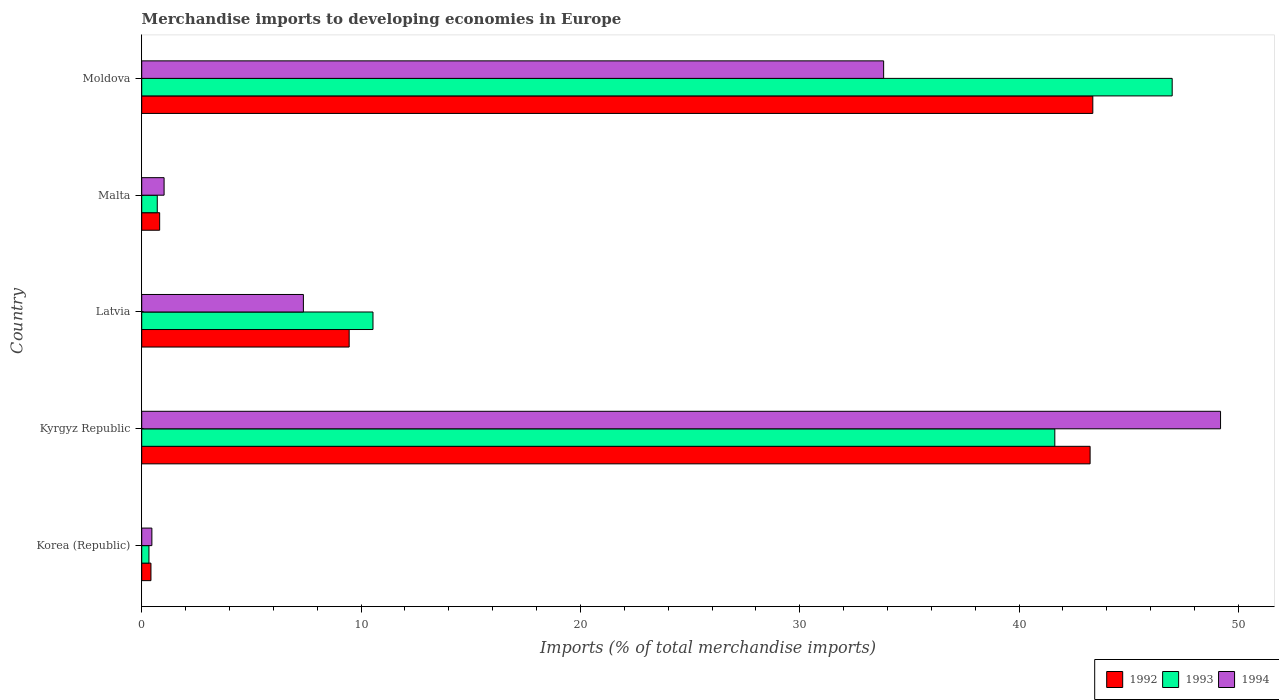Are the number of bars on each tick of the Y-axis equal?
Offer a terse response. Yes. How many bars are there on the 3rd tick from the bottom?
Keep it short and to the point. 3. What is the label of the 1st group of bars from the top?
Offer a terse response. Moldova. What is the percentage total merchandise imports in 1992 in Moldova?
Make the answer very short. 43.36. Across all countries, what is the maximum percentage total merchandise imports in 1992?
Offer a terse response. 43.36. Across all countries, what is the minimum percentage total merchandise imports in 1994?
Make the answer very short. 0.46. In which country was the percentage total merchandise imports in 1994 maximum?
Provide a short and direct response. Kyrgyz Republic. What is the total percentage total merchandise imports in 1992 in the graph?
Provide a short and direct response. 97.29. What is the difference between the percentage total merchandise imports in 1992 in Kyrgyz Republic and that in Malta?
Ensure brevity in your answer.  42.42. What is the difference between the percentage total merchandise imports in 1994 in Malta and the percentage total merchandise imports in 1993 in Korea (Republic)?
Offer a very short reply. 0.69. What is the average percentage total merchandise imports in 1992 per country?
Your answer should be compact. 19.46. What is the difference between the percentage total merchandise imports in 1994 and percentage total merchandise imports in 1993 in Moldova?
Your response must be concise. -13.15. What is the ratio of the percentage total merchandise imports in 1994 in Kyrgyz Republic to that in Latvia?
Provide a short and direct response. 6.67. Is the percentage total merchandise imports in 1992 in Kyrgyz Republic less than that in Malta?
Your answer should be compact. No. What is the difference between the highest and the second highest percentage total merchandise imports in 1993?
Your response must be concise. 5.35. What is the difference between the highest and the lowest percentage total merchandise imports in 1993?
Offer a terse response. 46.65. In how many countries, is the percentage total merchandise imports in 1993 greater than the average percentage total merchandise imports in 1993 taken over all countries?
Offer a terse response. 2. Is the sum of the percentage total merchandise imports in 1992 in Korea (Republic) and Kyrgyz Republic greater than the maximum percentage total merchandise imports in 1993 across all countries?
Your answer should be very brief. No. What does the 2nd bar from the top in Kyrgyz Republic represents?
Offer a very short reply. 1993. Is it the case that in every country, the sum of the percentage total merchandise imports in 1994 and percentage total merchandise imports in 1992 is greater than the percentage total merchandise imports in 1993?
Ensure brevity in your answer.  Yes. Are all the bars in the graph horizontal?
Make the answer very short. Yes. How many countries are there in the graph?
Give a very brief answer. 5. What is the difference between two consecutive major ticks on the X-axis?
Offer a very short reply. 10. Does the graph contain any zero values?
Provide a succinct answer. No. Does the graph contain grids?
Your response must be concise. No. Where does the legend appear in the graph?
Give a very brief answer. Bottom right. What is the title of the graph?
Give a very brief answer. Merchandise imports to developing economies in Europe. What is the label or title of the X-axis?
Give a very brief answer. Imports (% of total merchandise imports). What is the label or title of the Y-axis?
Your answer should be very brief. Country. What is the Imports (% of total merchandise imports) in 1992 in Korea (Republic)?
Offer a very short reply. 0.42. What is the Imports (% of total merchandise imports) of 1993 in Korea (Republic)?
Ensure brevity in your answer.  0.33. What is the Imports (% of total merchandise imports) of 1994 in Korea (Republic)?
Offer a very short reply. 0.46. What is the Imports (% of total merchandise imports) in 1992 in Kyrgyz Republic?
Your answer should be compact. 43.24. What is the Imports (% of total merchandise imports) in 1993 in Kyrgyz Republic?
Your answer should be very brief. 41.63. What is the Imports (% of total merchandise imports) in 1994 in Kyrgyz Republic?
Give a very brief answer. 49.18. What is the Imports (% of total merchandise imports) of 1992 in Latvia?
Keep it short and to the point. 9.46. What is the Imports (% of total merchandise imports) of 1993 in Latvia?
Ensure brevity in your answer.  10.54. What is the Imports (% of total merchandise imports) of 1994 in Latvia?
Make the answer very short. 7.37. What is the Imports (% of total merchandise imports) of 1992 in Malta?
Provide a short and direct response. 0.82. What is the Imports (% of total merchandise imports) of 1993 in Malta?
Make the answer very short. 0.71. What is the Imports (% of total merchandise imports) in 1994 in Malta?
Your answer should be compact. 1.02. What is the Imports (% of total merchandise imports) in 1992 in Moldova?
Provide a short and direct response. 43.36. What is the Imports (% of total merchandise imports) of 1993 in Moldova?
Provide a succinct answer. 46.98. What is the Imports (% of total merchandise imports) of 1994 in Moldova?
Make the answer very short. 33.82. Across all countries, what is the maximum Imports (% of total merchandise imports) in 1992?
Offer a very short reply. 43.36. Across all countries, what is the maximum Imports (% of total merchandise imports) in 1993?
Ensure brevity in your answer.  46.98. Across all countries, what is the maximum Imports (% of total merchandise imports) in 1994?
Keep it short and to the point. 49.18. Across all countries, what is the minimum Imports (% of total merchandise imports) in 1992?
Keep it short and to the point. 0.42. Across all countries, what is the minimum Imports (% of total merchandise imports) of 1993?
Offer a terse response. 0.33. Across all countries, what is the minimum Imports (% of total merchandise imports) in 1994?
Give a very brief answer. 0.46. What is the total Imports (% of total merchandise imports) of 1992 in the graph?
Ensure brevity in your answer.  97.29. What is the total Imports (% of total merchandise imports) in 1993 in the graph?
Provide a short and direct response. 100.19. What is the total Imports (% of total merchandise imports) of 1994 in the graph?
Your response must be concise. 91.86. What is the difference between the Imports (% of total merchandise imports) of 1992 in Korea (Republic) and that in Kyrgyz Republic?
Your answer should be very brief. -42.82. What is the difference between the Imports (% of total merchandise imports) in 1993 in Korea (Republic) and that in Kyrgyz Republic?
Your response must be concise. -41.3. What is the difference between the Imports (% of total merchandise imports) of 1994 in Korea (Republic) and that in Kyrgyz Republic?
Make the answer very short. -48.72. What is the difference between the Imports (% of total merchandise imports) in 1992 in Korea (Republic) and that in Latvia?
Offer a very short reply. -9.04. What is the difference between the Imports (% of total merchandise imports) of 1993 in Korea (Republic) and that in Latvia?
Your response must be concise. -10.21. What is the difference between the Imports (% of total merchandise imports) in 1994 in Korea (Republic) and that in Latvia?
Keep it short and to the point. -6.91. What is the difference between the Imports (% of total merchandise imports) in 1992 in Korea (Republic) and that in Malta?
Provide a succinct answer. -0.4. What is the difference between the Imports (% of total merchandise imports) in 1993 in Korea (Republic) and that in Malta?
Keep it short and to the point. -0.38. What is the difference between the Imports (% of total merchandise imports) of 1994 in Korea (Republic) and that in Malta?
Offer a terse response. -0.56. What is the difference between the Imports (% of total merchandise imports) of 1992 in Korea (Republic) and that in Moldova?
Your response must be concise. -42.94. What is the difference between the Imports (% of total merchandise imports) in 1993 in Korea (Republic) and that in Moldova?
Make the answer very short. -46.65. What is the difference between the Imports (% of total merchandise imports) of 1994 in Korea (Republic) and that in Moldova?
Provide a succinct answer. -33.36. What is the difference between the Imports (% of total merchandise imports) in 1992 in Kyrgyz Republic and that in Latvia?
Provide a succinct answer. 33.78. What is the difference between the Imports (% of total merchandise imports) in 1993 in Kyrgyz Republic and that in Latvia?
Your answer should be compact. 31.08. What is the difference between the Imports (% of total merchandise imports) in 1994 in Kyrgyz Republic and that in Latvia?
Offer a very short reply. 41.81. What is the difference between the Imports (% of total merchandise imports) of 1992 in Kyrgyz Republic and that in Malta?
Your answer should be compact. 42.42. What is the difference between the Imports (% of total merchandise imports) in 1993 in Kyrgyz Republic and that in Malta?
Offer a very short reply. 40.92. What is the difference between the Imports (% of total merchandise imports) in 1994 in Kyrgyz Republic and that in Malta?
Your answer should be compact. 48.16. What is the difference between the Imports (% of total merchandise imports) of 1992 in Kyrgyz Republic and that in Moldova?
Provide a short and direct response. -0.12. What is the difference between the Imports (% of total merchandise imports) in 1993 in Kyrgyz Republic and that in Moldova?
Offer a terse response. -5.35. What is the difference between the Imports (% of total merchandise imports) in 1994 in Kyrgyz Republic and that in Moldova?
Provide a short and direct response. 15.36. What is the difference between the Imports (% of total merchandise imports) in 1992 in Latvia and that in Malta?
Keep it short and to the point. 8.64. What is the difference between the Imports (% of total merchandise imports) of 1993 in Latvia and that in Malta?
Provide a short and direct response. 9.83. What is the difference between the Imports (% of total merchandise imports) in 1994 in Latvia and that in Malta?
Ensure brevity in your answer.  6.35. What is the difference between the Imports (% of total merchandise imports) of 1992 in Latvia and that in Moldova?
Your response must be concise. -33.9. What is the difference between the Imports (% of total merchandise imports) in 1993 in Latvia and that in Moldova?
Your answer should be very brief. -36.44. What is the difference between the Imports (% of total merchandise imports) of 1994 in Latvia and that in Moldova?
Give a very brief answer. -26.45. What is the difference between the Imports (% of total merchandise imports) of 1992 in Malta and that in Moldova?
Give a very brief answer. -42.54. What is the difference between the Imports (% of total merchandise imports) of 1993 in Malta and that in Moldova?
Your answer should be compact. -46.27. What is the difference between the Imports (% of total merchandise imports) of 1994 in Malta and that in Moldova?
Keep it short and to the point. -32.8. What is the difference between the Imports (% of total merchandise imports) of 1992 in Korea (Republic) and the Imports (% of total merchandise imports) of 1993 in Kyrgyz Republic?
Provide a succinct answer. -41.21. What is the difference between the Imports (% of total merchandise imports) in 1992 in Korea (Republic) and the Imports (% of total merchandise imports) in 1994 in Kyrgyz Republic?
Offer a terse response. -48.76. What is the difference between the Imports (% of total merchandise imports) in 1993 in Korea (Republic) and the Imports (% of total merchandise imports) in 1994 in Kyrgyz Republic?
Your answer should be compact. -48.85. What is the difference between the Imports (% of total merchandise imports) in 1992 in Korea (Republic) and the Imports (% of total merchandise imports) in 1993 in Latvia?
Keep it short and to the point. -10.12. What is the difference between the Imports (% of total merchandise imports) of 1992 in Korea (Republic) and the Imports (% of total merchandise imports) of 1994 in Latvia?
Your response must be concise. -6.95. What is the difference between the Imports (% of total merchandise imports) in 1993 in Korea (Republic) and the Imports (% of total merchandise imports) in 1994 in Latvia?
Offer a very short reply. -7.04. What is the difference between the Imports (% of total merchandise imports) of 1992 in Korea (Republic) and the Imports (% of total merchandise imports) of 1993 in Malta?
Offer a very short reply. -0.29. What is the difference between the Imports (% of total merchandise imports) in 1992 in Korea (Republic) and the Imports (% of total merchandise imports) in 1994 in Malta?
Your answer should be very brief. -0.6. What is the difference between the Imports (% of total merchandise imports) of 1993 in Korea (Republic) and the Imports (% of total merchandise imports) of 1994 in Malta?
Make the answer very short. -0.69. What is the difference between the Imports (% of total merchandise imports) of 1992 in Korea (Republic) and the Imports (% of total merchandise imports) of 1993 in Moldova?
Your answer should be very brief. -46.56. What is the difference between the Imports (% of total merchandise imports) in 1992 in Korea (Republic) and the Imports (% of total merchandise imports) in 1994 in Moldova?
Keep it short and to the point. -33.4. What is the difference between the Imports (% of total merchandise imports) of 1993 in Korea (Republic) and the Imports (% of total merchandise imports) of 1994 in Moldova?
Your answer should be compact. -33.49. What is the difference between the Imports (% of total merchandise imports) in 1992 in Kyrgyz Republic and the Imports (% of total merchandise imports) in 1993 in Latvia?
Your answer should be very brief. 32.69. What is the difference between the Imports (% of total merchandise imports) of 1992 in Kyrgyz Republic and the Imports (% of total merchandise imports) of 1994 in Latvia?
Offer a terse response. 35.87. What is the difference between the Imports (% of total merchandise imports) of 1993 in Kyrgyz Republic and the Imports (% of total merchandise imports) of 1994 in Latvia?
Offer a terse response. 34.26. What is the difference between the Imports (% of total merchandise imports) of 1992 in Kyrgyz Republic and the Imports (% of total merchandise imports) of 1993 in Malta?
Offer a very short reply. 42.53. What is the difference between the Imports (% of total merchandise imports) of 1992 in Kyrgyz Republic and the Imports (% of total merchandise imports) of 1994 in Malta?
Provide a succinct answer. 42.22. What is the difference between the Imports (% of total merchandise imports) of 1993 in Kyrgyz Republic and the Imports (% of total merchandise imports) of 1994 in Malta?
Your answer should be compact. 40.61. What is the difference between the Imports (% of total merchandise imports) of 1992 in Kyrgyz Republic and the Imports (% of total merchandise imports) of 1993 in Moldova?
Your answer should be compact. -3.74. What is the difference between the Imports (% of total merchandise imports) in 1992 in Kyrgyz Republic and the Imports (% of total merchandise imports) in 1994 in Moldova?
Offer a terse response. 9.41. What is the difference between the Imports (% of total merchandise imports) of 1993 in Kyrgyz Republic and the Imports (% of total merchandise imports) of 1994 in Moldova?
Provide a short and direct response. 7.8. What is the difference between the Imports (% of total merchandise imports) in 1992 in Latvia and the Imports (% of total merchandise imports) in 1993 in Malta?
Your response must be concise. 8.75. What is the difference between the Imports (% of total merchandise imports) in 1992 in Latvia and the Imports (% of total merchandise imports) in 1994 in Malta?
Your response must be concise. 8.44. What is the difference between the Imports (% of total merchandise imports) in 1993 in Latvia and the Imports (% of total merchandise imports) in 1994 in Malta?
Your response must be concise. 9.52. What is the difference between the Imports (% of total merchandise imports) of 1992 in Latvia and the Imports (% of total merchandise imports) of 1993 in Moldova?
Give a very brief answer. -37.52. What is the difference between the Imports (% of total merchandise imports) of 1992 in Latvia and the Imports (% of total merchandise imports) of 1994 in Moldova?
Your response must be concise. -24.37. What is the difference between the Imports (% of total merchandise imports) in 1993 in Latvia and the Imports (% of total merchandise imports) in 1994 in Moldova?
Offer a terse response. -23.28. What is the difference between the Imports (% of total merchandise imports) in 1992 in Malta and the Imports (% of total merchandise imports) in 1993 in Moldova?
Give a very brief answer. -46.16. What is the difference between the Imports (% of total merchandise imports) in 1992 in Malta and the Imports (% of total merchandise imports) in 1994 in Moldova?
Provide a succinct answer. -33.01. What is the difference between the Imports (% of total merchandise imports) of 1993 in Malta and the Imports (% of total merchandise imports) of 1994 in Moldova?
Offer a very short reply. -33.12. What is the average Imports (% of total merchandise imports) in 1992 per country?
Give a very brief answer. 19.46. What is the average Imports (% of total merchandise imports) of 1993 per country?
Keep it short and to the point. 20.04. What is the average Imports (% of total merchandise imports) of 1994 per country?
Ensure brevity in your answer.  18.37. What is the difference between the Imports (% of total merchandise imports) of 1992 and Imports (% of total merchandise imports) of 1993 in Korea (Republic)?
Offer a terse response. 0.09. What is the difference between the Imports (% of total merchandise imports) of 1992 and Imports (% of total merchandise imports) of 1994 in Korea (Republic)?
Your answer should be compact. -0.04. What is the difference between the Imports (% of total merchandise imports) in 1993 and Imports (% of total merchandise imports) in 1994 in Korea (Republic)?
Provide a short and direct response. -0.13. What is the difference between the Imports (% of total merchandise imports) in 1992 and Imports (% of total merchandise imports) in 1993 in Kyrgyz Republic?
Your answer should be compact. 1.61. What is the difference between the Imports (% of total merchandise imports) in 1992 and Imports (% of total merchandise imports) in 1994 in Kyrgyz Republic?
Make the answer very short. -5.95. What is the difference between the Imports (% of total merchandise imports) in 1993 and Imports (% of total merchandise imports) in 1994 in Kyrgyz Republic?
Your response must be concise. -7.56. What is the difference between the Imports (% of total merchandise imports) in 1992 and Imports (% of total merchandise imports) in 1993 in Latvia?
Offer a very short reply. -1.09. What is the difference between the Imports (% of total merchandise imports) of 1992 and Imports (% of total merchandise imports) of 1994 in Latvia?
Provide a succinct answer. 2.09. What is the difference between the Imports (% of total merchandise imports) of 1993 and Imports (% of total merchandise imports) of 1994 in Latvia?
Your response must be concise. 3.17. What is the difference between the Imports (% of total merchandise imports) of 1992 and Imports (% of total merchandise imports) of 1993 in Malta?
Keep it short and to the point. 0.11. What is the difference between the Imports (% of total merchandise imports) in 1992 and Imports (% of total merchandise imports) in 1994 in Malta?
Your answer should be very brief. -0.2. What is the difference between the Imports (% of total merchandise imports) of 1993 and Imports (% of total merchandise imports) of 1994 in Malta?
Offer a very short reply. -0.31. What is the difference between the Imports (% of total merchandise imports) in 1992 and Imports (% of total merchandise imports) in 1993 in Moldova?
Give a very brief answer. -3.62. What is the difference between the Imports (% of total merchandise imports) in 1992 and Imports (% of total merchandise imports) in 1994 in Moldova?
Make the answer very short. 9.54. What is the difference between the Imports (% of total merchandise imports) in 1993 and Imports (% of total merchandise imports) in 1994 in Moldova?
Ensure brevity in your answer.  13.15. What is the ratio of the Imports (% of total merchandise imports) in 1992 in Korea (Republic) to that in Kyrgyz Republic?
Offer a very short reply. 0.01. What is the ratio of the Imports (% of total merchandise imports) of 1993 in Korea (Republic) to that in Kyrgyz Republic?
Make the answer very short. 0.01. What is the ratio of the Imports (% of total merchandise imports) in 1994 in Korea (Republic) to that in Kyrgyz Republic?
Offer a very short reply. 0.01. What is the ratio of the Imports (% of total merchandise imports) in 1992 in Korea (Republic) to that in Latvia?
Provide a succinct answer. 0.04. What is the ratio of the Imports (% of total merchandise imports) of 1993 in Korea (Republic) to that in Latvia?
Provide a succinct answer. 0.03. What is the ratio of the Imports (% of total merchandise imports) of 1994 in Korea (Republic) to that in Latvia?
Ensure brevity in your answer.  0.06. What is the ratio of the Imports (% of total merchandise imports) of 1992 in Korea (Republic) to that in Malta?
Give a very brief answer. 0.51. What is the ratio of the Imports (% of total merchandise imports) in 1993 in Korea (Republic) to that in Malta?
Ensure brevity in your answer.  0.47. What is the ratio of the Imports (% of total merchandise imports) in 1994 in Korea (Republic) to that in Malta?
Give a very brief answer. 0.45. What is the ratio of the Imports (% of total merchandise imports) in 1992 in Korea (Republic) to that in Moldova?
Keep it short and to the point. 0.01. What is the ratio of the Imports (% of total merchandise imports) in 1993 in Korea (Republic) to that in Moldova?
Keep it short and to the point. 0.01. What is the ratio of the Imports (% of total merchandise imports) of 1994 in Korea (Republic) to that in Moldova?
Make the answer very short. 0.01. What is the ratio of the Imports (% of total merchandise imports) in 1992 in Kyrgyz Republic to that in Latvia?
Provide a short and direct response. 4.57. What is the ratio of the Imports (% of total merchandise imports) of 1993 in Kyrgyz Republic to that in Latvia?
Offer a very short reply. 3.95. What is the ratio of the Imports (% of total merchandise imports) in 1994 in Kyrgyz Republic to that in Latvia?
Your answer should be compact. 6.67. What is the ratio of the Imports (% of total merchandise imports) in 1992 in Kyrgyz Republic to that in Malta?
Offer a very short reply. 52.87. What is the ratio of the Imports (% of total merchandise imports) of 1993 in Kyrgyz Republic to that in Malta?
Provide a succinct answer. 58.77. What is the ratio of the Imports (% of total merchandise imports) of 1994 in Kyrgyz Republic to that in Malta?
Give a very brief answer. 48.22. What is the ratio of the Imports (% of total merchandise imports) in 1992 in Kyrgyz Republic to that in Moldova?
Provide a succinct answer. 1. What is the ratio of the Imports (% of total merchandise imports) of 1993 in Kyrgyz Republic to that in Moldova?
Offer a very short reply. 0.89. What is the ratio of the Imports (% of total merchandise imports) in 1994 in Kyrgyz Republic to that in Moldova?
Offer a terse response. 1.45. What is the ratio of the Imports (% of total merchandise imports) in 1992 in Latvia to that in Malta?
Keep it short and to the point. 11.56. What is the ratio of the Imports (% of total merchandise imports) in 1993 in Latvia to that in Malta?
Make the answer very short. 14.88. What is the ratio of the Imports (% of total merchandise imports) in 1994 in Latvia to that in Malta?
Your response must be concise. 7.23. What is the ratio of the Imports (% of total merchandise imports) of 1992 in Latvia to that in Moldova?
Give a very brief answer. 0.22. What is the ratio of the Imports (% of total merchandise imports) in 1993 in Latvia to that in Moldova?
Offer a terse response. 0.22. What is the ratio of the Imports (% of total merchandise imports) of 1994 in Latvia to that in Moldova?
Keep it short and to the point. 0.22. What is the ratio of the Imports (% of total merchandise imports) in 1992 in Malta to that in Moldova?
Offer a very short reply. 0.02. What is the ratio of the Imports (% of total merchandise imports) in 1993 in Malta to that in Moldova?
Your response must be concise. 0.02. What is the ratio of the Imports (% of total merchandise imports) in 1994 in Malta to that in Moldova?
Your answer should be compact. 0.03. What is the difference between the highest and the second highest Imports (% of total merchandise imports) in 1992?
Provide a succinct answer. 0.12. What is the difference between the highest and the second highest Imports (% of total merchandise imports) of 1993?
Provide a succinct answer. 5.35. What is the difference between the highest and the second highest Imports (% of total merchandise imports) of 1994?
Make the answer very short. 15.36. What is the difference between the highest and the lowest Imports (% of total merchandise imports) in 1992?
Offer a terse response. 42.94. What is the difference between the highest and the lowest Imports (% of total merchandise imports) of 1993?
Your answer should be compact. 46.65. What is the difference between the highest and the lowest Imports (% of total merchandise imports) in 1994?
Provide a short and direct response. 48.72. 